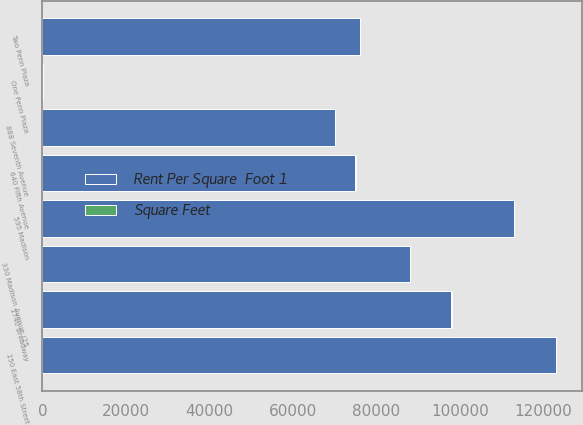Convert chart to OTSL. <chart><loc_0><loc_0><loc_500><loc_500><stacked_bar_chart><ecel><fcel>One Penn Plaza<fcel>150 East 58th Street<fcel>595 Madison<fcel>1740 Broadway<fcel>330 Madison Avenue (25<fcel>Two Penn Plaza<fcel>640 Fifth Avenue<fcel>888 Seventh Avenue<nl><fcel>Rent Per Square  Foot 1<fcel>69.79<fcel>123000<fcel>113000<fcel>98000<fcel>88000<fcel>76000<fcel>75000<fcel>70000<nl><fcel>Square Feet<fcel>39.57<fcel>45.71<fcel>53.83<fcel>54.42<fcel>46.02<fcel>38.12<fcel>69.79<fcel>47.74<nl></chart> 